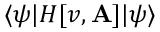<formula> <loc_0><loc_0><loc_500><loc_500>\langle \psi | H [ v , A ] | \psi \rangle</formula> 